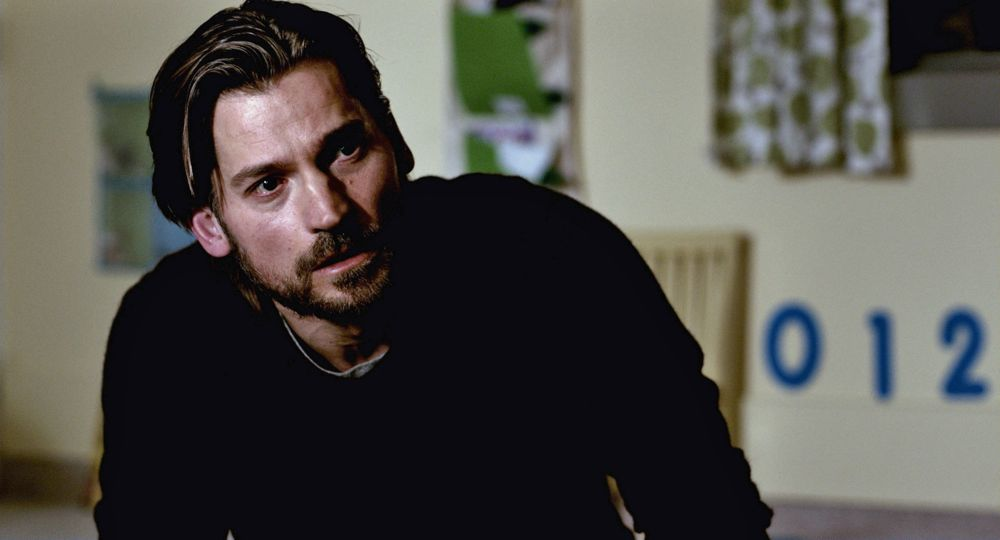What emotions does the man's facial expression convey? The man's facial expression conveys a sense of seriousness and depth. His slightly furrowed brow and focused expression suggest that he is deeply contemplative or concerned about a particular matter. This reflective demeanor might be indicative of his current mood or the gravity of the situation he is pondering. 